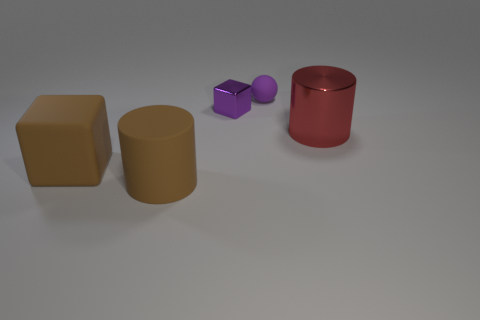Add 5 brown blocks. How many objects exist? 10 Subtract all brown cylinders. How many cylinders are left? 1 Subtract all balls. How many objects are left? 4 Subtract 0 yellow cylinders. How many objects are left? 5 Subtract 1 cubes. How many cubes are left? 1 Subtract all blue spheres. Subtract all blue cylinders. How many spheres are left? 1 Subtract all purple cubes. How many red cylinders are left? 1 Subtract all small purple cubes. Subtract all large blue cubes. How many objects are left? 4 Add 5 red things. How many red things are left? 6 Add 5 small yellow metallic cylinders. How many small yellow metallic cylinders exist? 5 